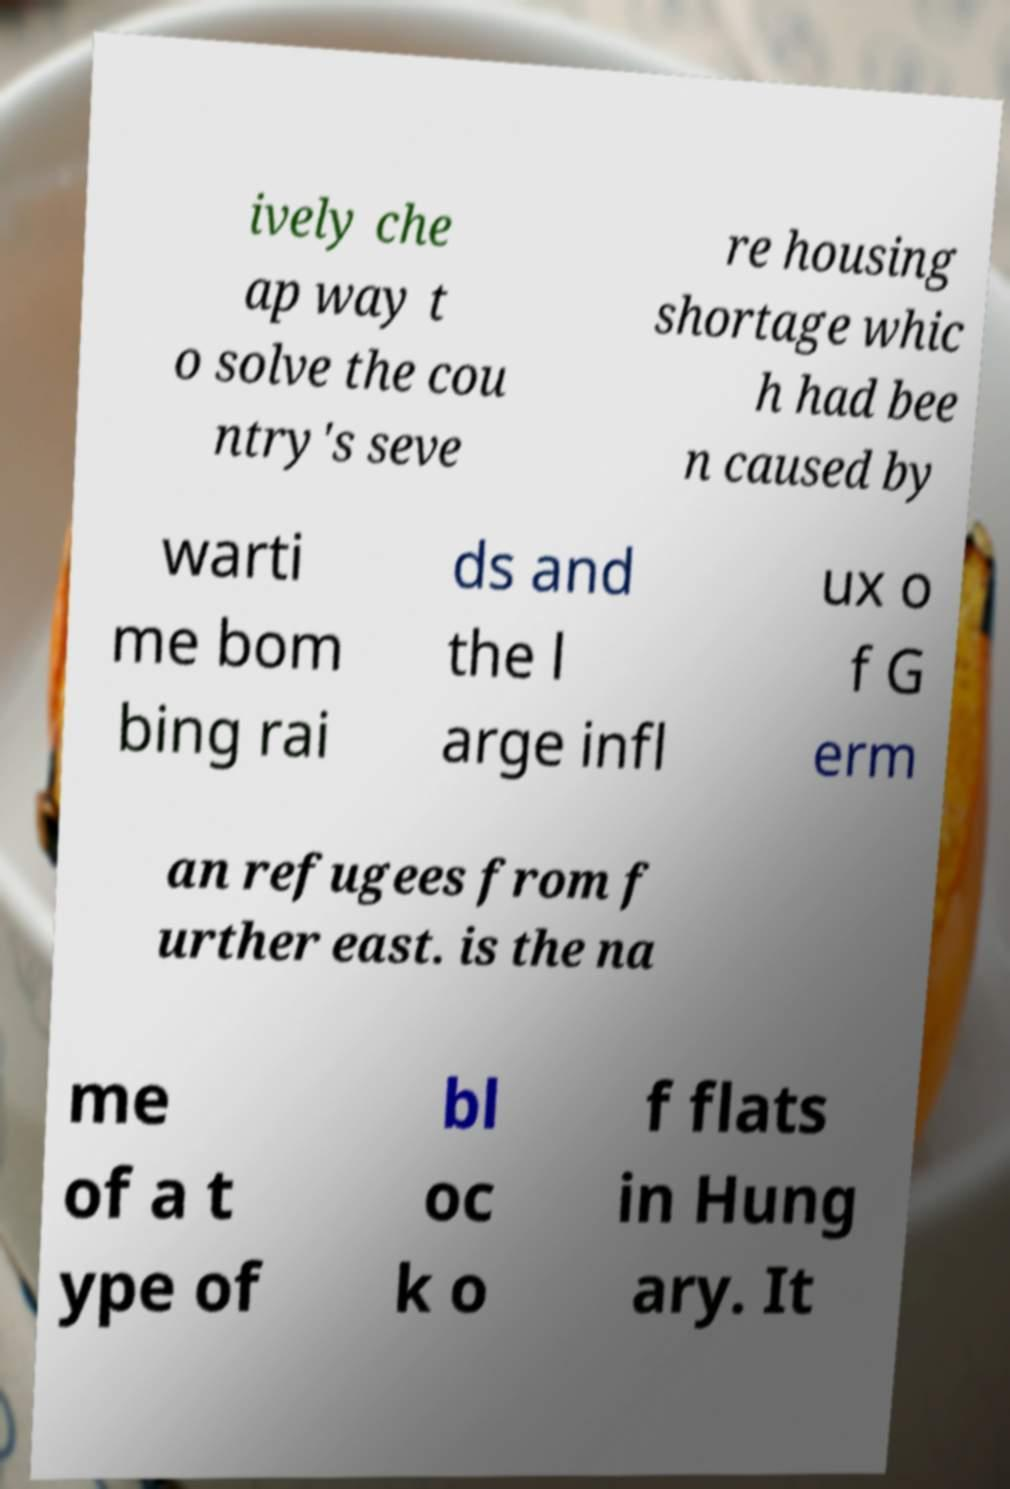I need the written content from this picture converted into text. Can you do that? ively che ap way t o solve the cou ntry's seve re housing shortage whic h had bee n caused by warti me bom bing rai ds and the l arge infl ux o f G erm an refugees from f urther east. is the na me of a t ype of bl oc k o f flats in Hung ary. It 